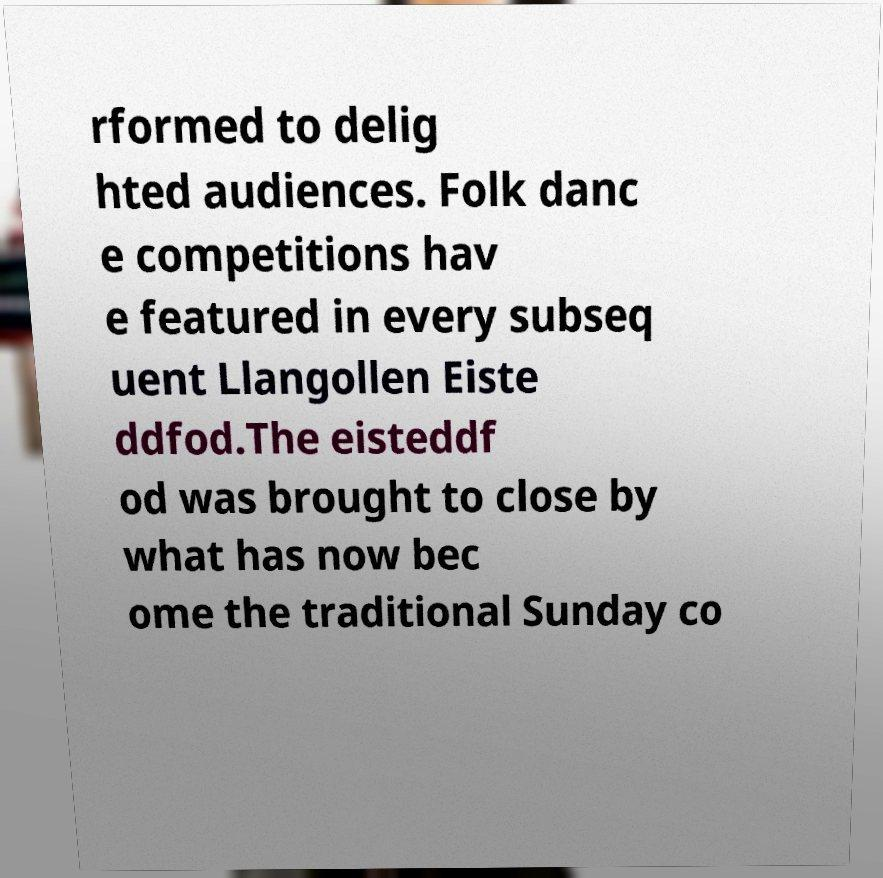Can you accurately transcribe the text from the provided image for me? rformed to delig hted audiences. Folk danc e competitions hav e featured in every subseq uent Llangollen Eiste ddfod.The eisteddf od was brought to close by what has now bec ome the traditional Sunday co 